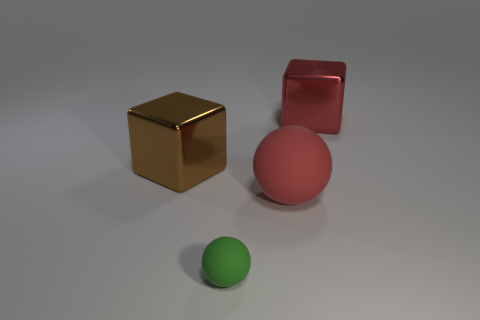Which object in the image appears to be the smallest? The smallest object in the image appears to be the green sphere. It has a smaller diameter compared to the red sphere and is visibly smaller than both the gold and red blocks. Is the lighting consistent across all objects? Yes, the lighting on the objects is consistent. Each object has a shadow directed away from the light source, suggesting the light is coming from the same direction for all the objects. This results in the objects having a similar pattern of highlights and shading. 